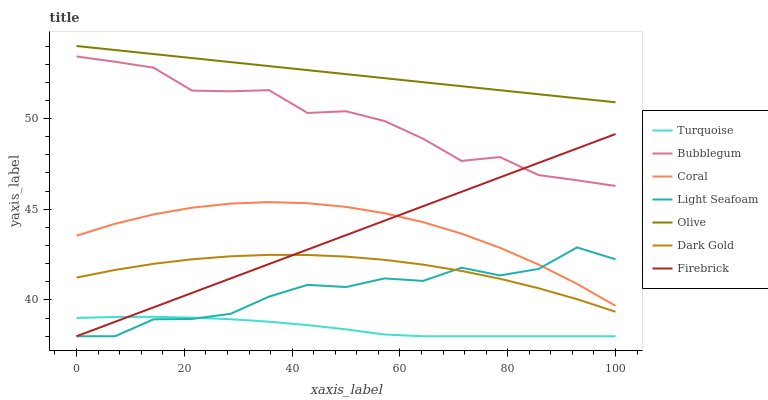Does Turquoise have the minimum area under the curve?
Answer yes or no. Yes. Does Olive have the maximum area under the curve?
Answer yes or no. Yes. Does Dark Gold have the minimum area under the curve?
Answer yes or no. No. Does Dark Gold have the maximum area under the curve?
Answer yes or no. No. Is Olive the smoothest?
Answer yes or no. Yes. Is Light Seafoam the roughest?
Answer yes or no. Yes. Is Dark Gold the smoothest?
Answer yes or no. No. Is Dark Gold the roughest?
Answer yes or no. No. Does Turquoise have the lowest value?
Answer yes or no. Yes. Does Dark Gold have the lowest value?
Answer yes or no. No. Does Olive have the highest value?
Answer yes or no. Yes. Does Dark Gold have the highest value?
Answer yes or no. No. Is Turquoise less than Dark Gold?
Answer yes or no. Yes. Is Olive greater than Light Seafoam?
Answer yes or no. Yes. Does Light Seafoam intersect Firebrick?
Answer yes or no. Yes. Is Light Seafoam less than Firebrick?
Answer yes or no. No. Is Light Seafoam greater than Firebrick?
Answer yes or no. No. Does Turquoise intersect Dark Gold?
Answer yes or no. No. 